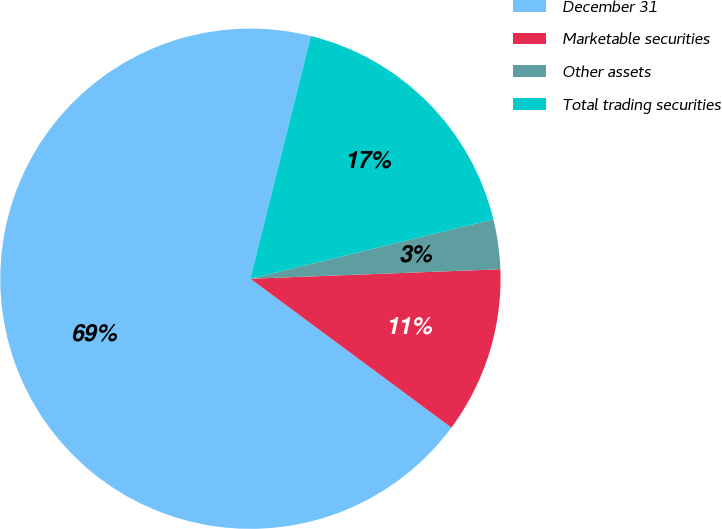<chart> <loc_0><loc_0><loc_500><loc_500><pie_chart><fcel>December 31<fcel>Marketable securities<fcel>Other assets<fcel>Total trading securities<nl><fcel>68.74%<fcel>10.75%<fcel>3.21%<fcel>17.3%<nl></chart> 